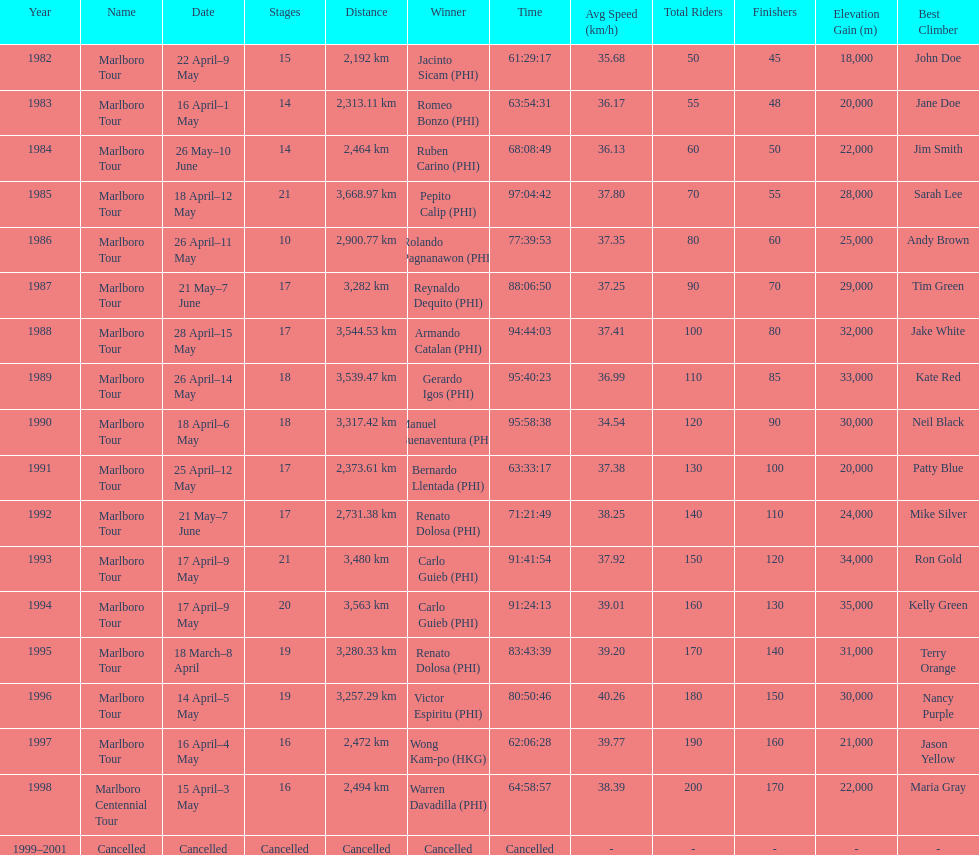What was the largest distance traveled for the marlboro tour? 3,668.97 km. 